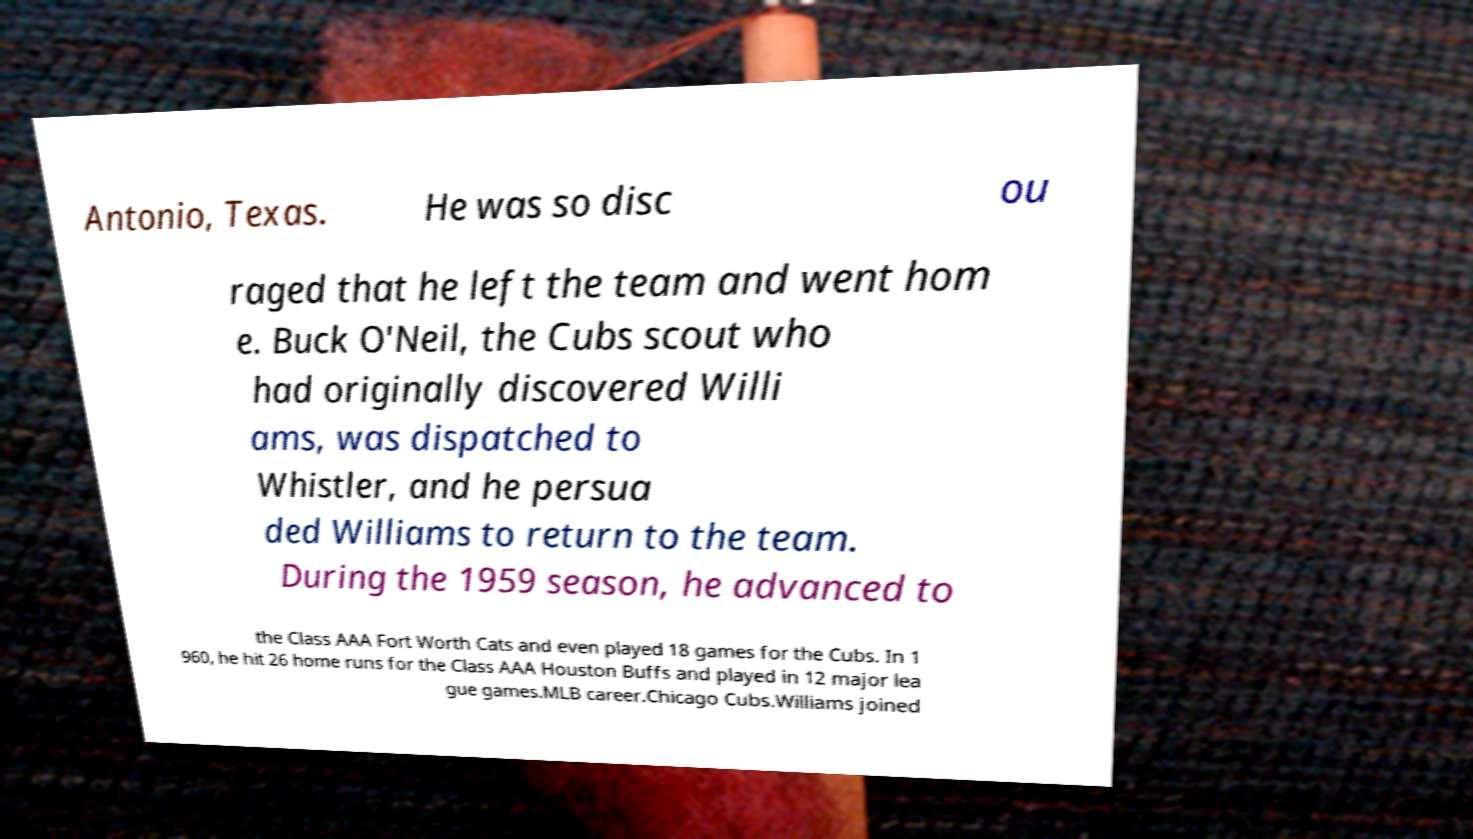Please read and relay the text visible in this image. What does it say? Antonio, Texas. He was so disc ou raged that he left the team and went hom e. Buck O'Neil, the Cubs scout who had originally discovered Willi ams, was dispatched to Whistler, and he persua ded Williams to return to the team. During the 1959 season, he advanced to the Class AAA Fort Worth Cats and even played 18 games for the Cubs. In 1 960, he hit 26 home runs for the Class AAA Houston Buffs and played in 12 major lea gue games.MLB career.Chicago Cubs.Williams joined 